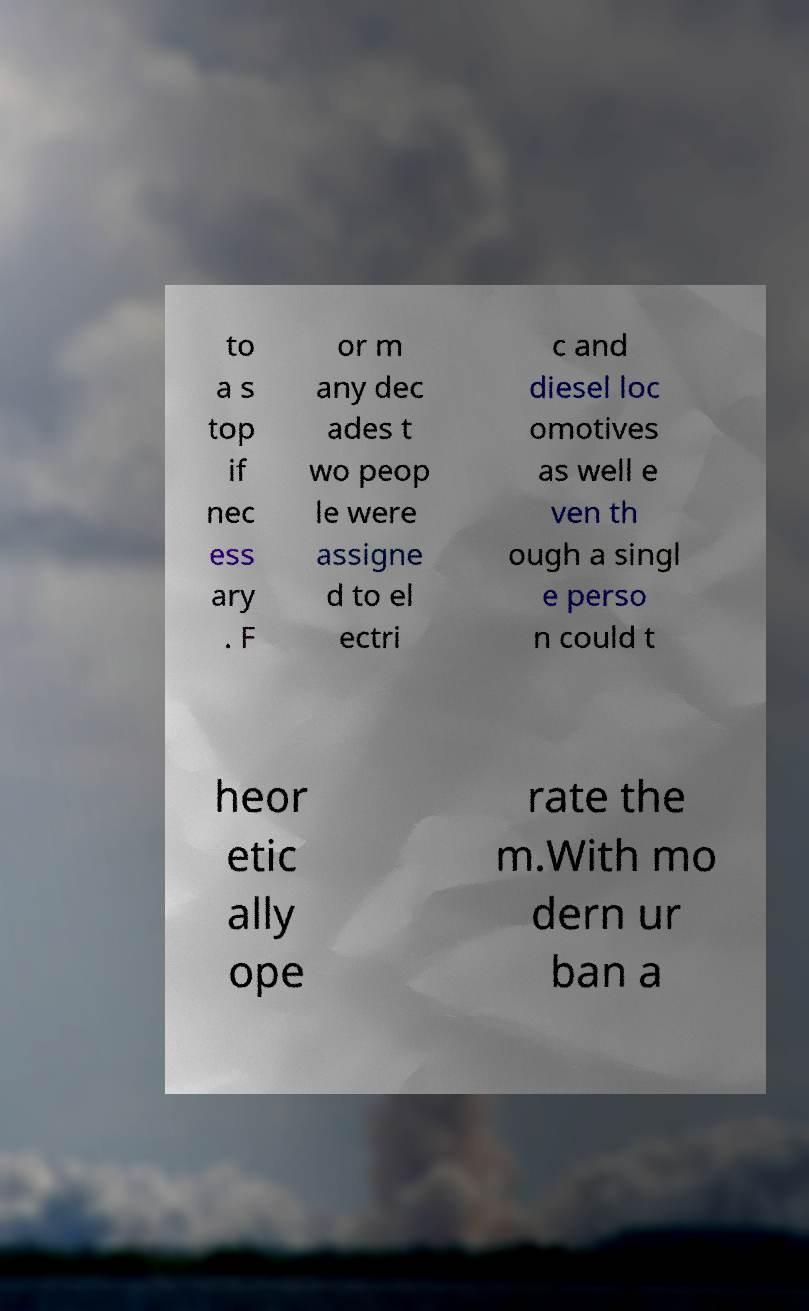I need the written content from this picture converted into text. Can you do that? to a s top if nec ess ary . F or m any dec ades t wo peop le were assigne d to el ectri c and diesel loc omotives as well e ven th ough a singl e perso n could t heor etic ally ope rate the m.With mo dern ur ban a 